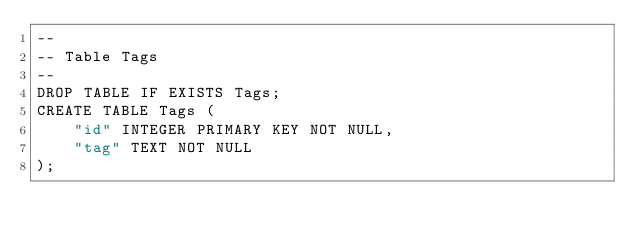Convert code to text. <code><loc_0><loc_0><loc_500><loc_500><_SQL_>--
-- Table Tags
--
DROP TABLE IF EXISTS Tags;
CREATE TABLE Tags (
    "id" INTEGER PRIMARY KEY NOT NULL,
    "tag" TEXT NOT NULL
);
</code> 